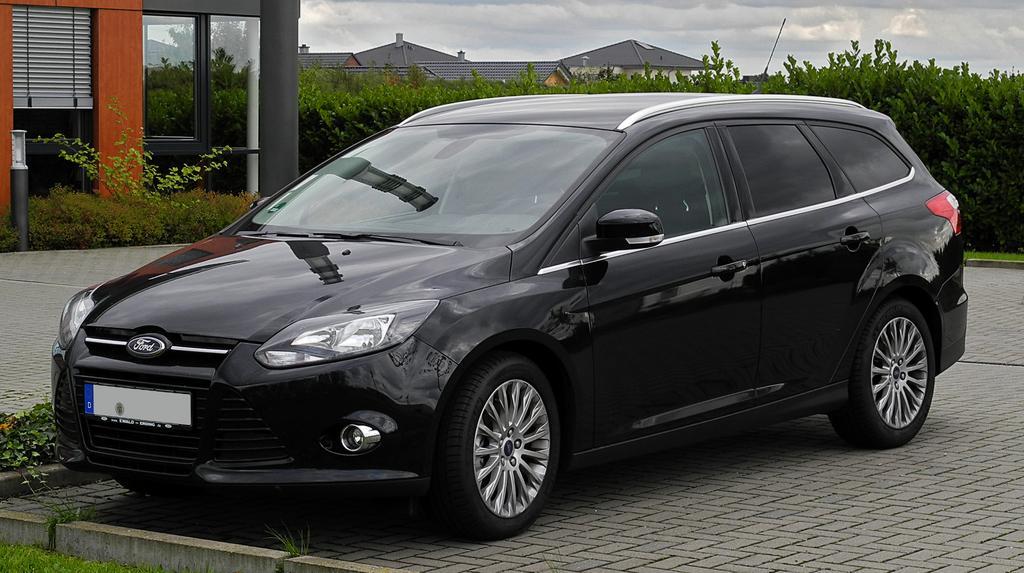Describe this image in one or two sentences. Here we can see a car on the road. In the background there are buildings,glass doors,trees and clouds in the sky. 